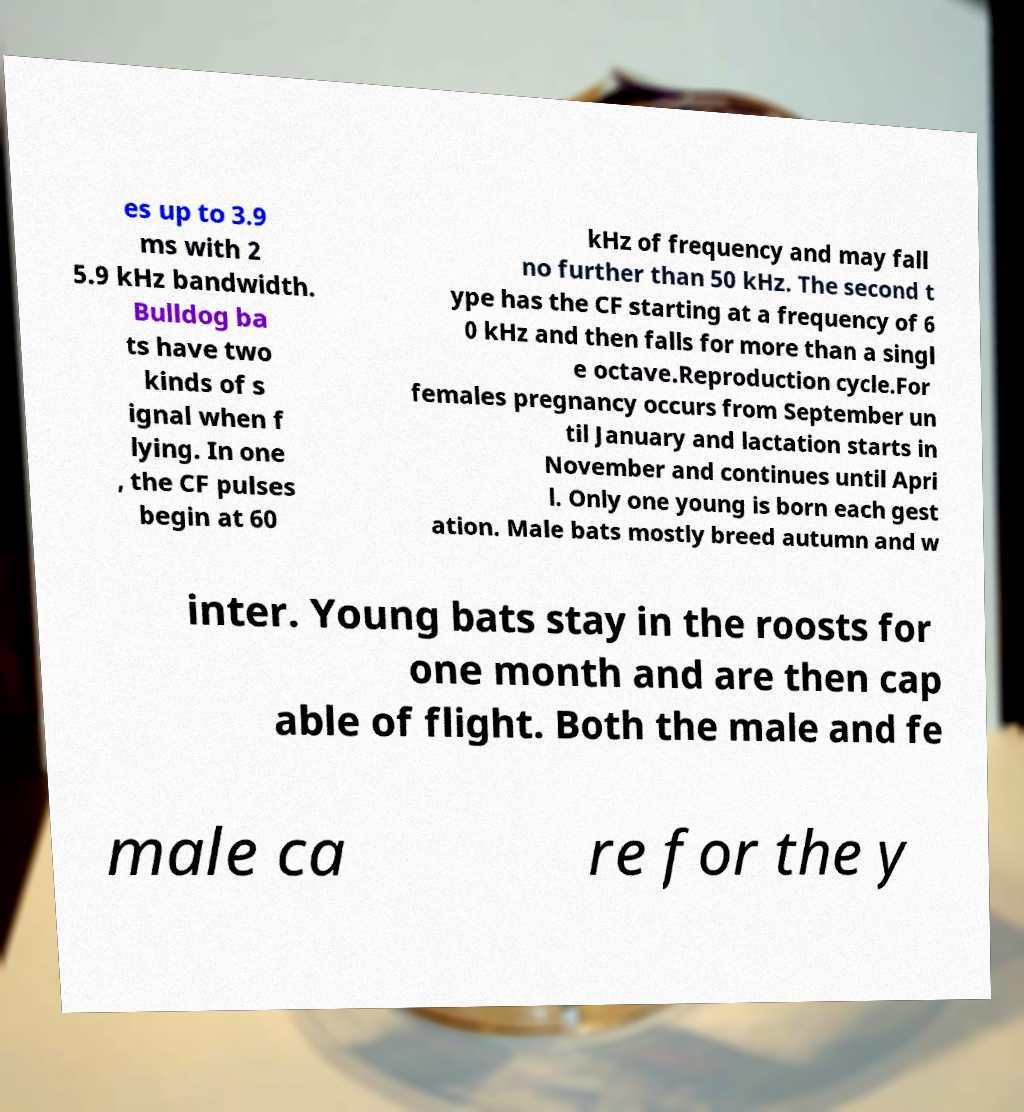Could you extract and type out the text from this image? es up to 3.9 ms with 2 5.9 kHz bandwidth. Bulldog ba ts have two kinds of s ignal when f lying. In one , the CF pulses begin at 60 kHz of frequency and may fall no further than 50 kHz. The second t ype has the CF starting at a frequency of 6 0 kHz and then falls for more than a singl e octave.Reproduction cycle.For females pregnancy occurs from September un til January and lactation starts in November and continues until Apri l. Only one young is born each gest ation. Male bats mostly breed autumn and w inter. Young bats stay in the roosts for one month and are then cap able of flight. Both the male and fe male ca re for the y 